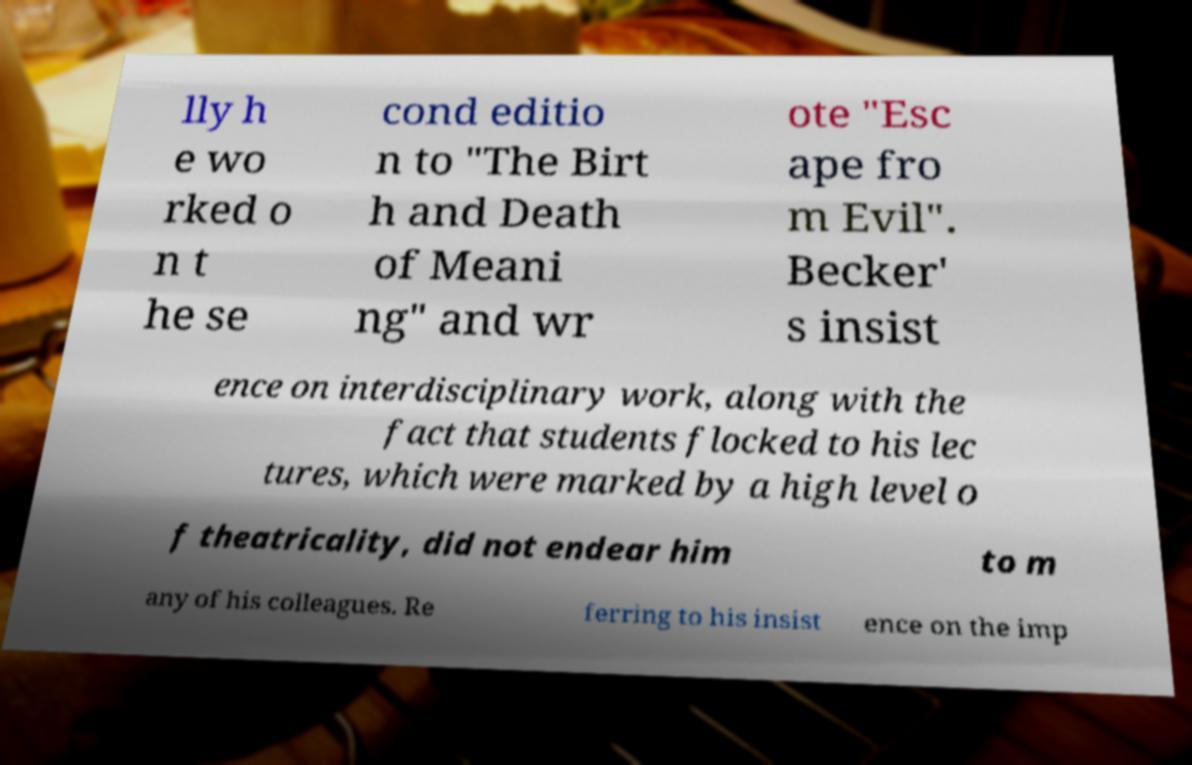What messages or text are displayed in this image? I need them in a readable, typed format. lly h e wo rked o n t he se cond editio n to "The Birt h and Death of Meani ng" and wr ote "Esc ape fro m Evil". Becker' s insist ence on interdisciplinary work, along with the fact that students flocked to his lec tures, which were marked by a high level o f theatricality, did not endear him to m any of his colleagues. Re ferring to his insist ence on the imp 